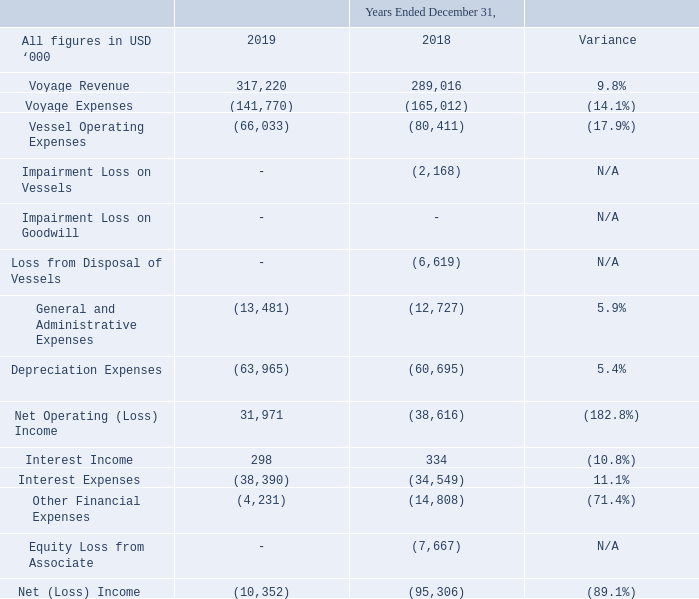A. Operating Results
YEAR ENDED DECEMBER 31, 2019 COMPARED TO YEAR ENDED DECEMBER 31, 2018
Management believes that net voyage revenue, a non-GAAP financial measure, provides additional meaningful information because it enables us to compare the profitability of our vessels which are employed under bareboat charters, spot related time charters and spot charters. Net voyage revenues divided by the number of days on the charter provides the Time Charter Equivalent (TCE) Rate. Net voyage revenues and TCE rates are widely used by investors and analysts in the tanker shipping industry for comparing the financial performance of companies and for preparing industry averages. We believe that our method of calculating net voyage revenue is consistent with industry standards. The table below reconciles our net voyage revenues to voyage revenues.
What are the respective voyage revenue in 2018 and 2019?
Answer scale should be: thousand. 289,016, 317,220. What are the respective voyage expenses in 2018 and 2019?
Answer scale should be: thousand. 165,012, 141,770. What are the respective vessel operating expenses in 2018 and 2019?
Answer scale should be: thousand. 80,411, 66,033. What is the percentage change in the voyage revenue between 2018 and 2019?
Answer scale should be: percent. (317,220-289,016)/289,016 
Answer: 9.76. What is the percentage change in the voyage expenses between 2018 and 2019?
Answer scale should be: percent. (141,770 - 165,012)/165,012 
Answer: -14.09. What is the percentage change in the vessel operating expenses between 2018 and 2019?
Answer scale should be: percent. (66,033 - 80,411)/80,411 
Answer: -17.88. 